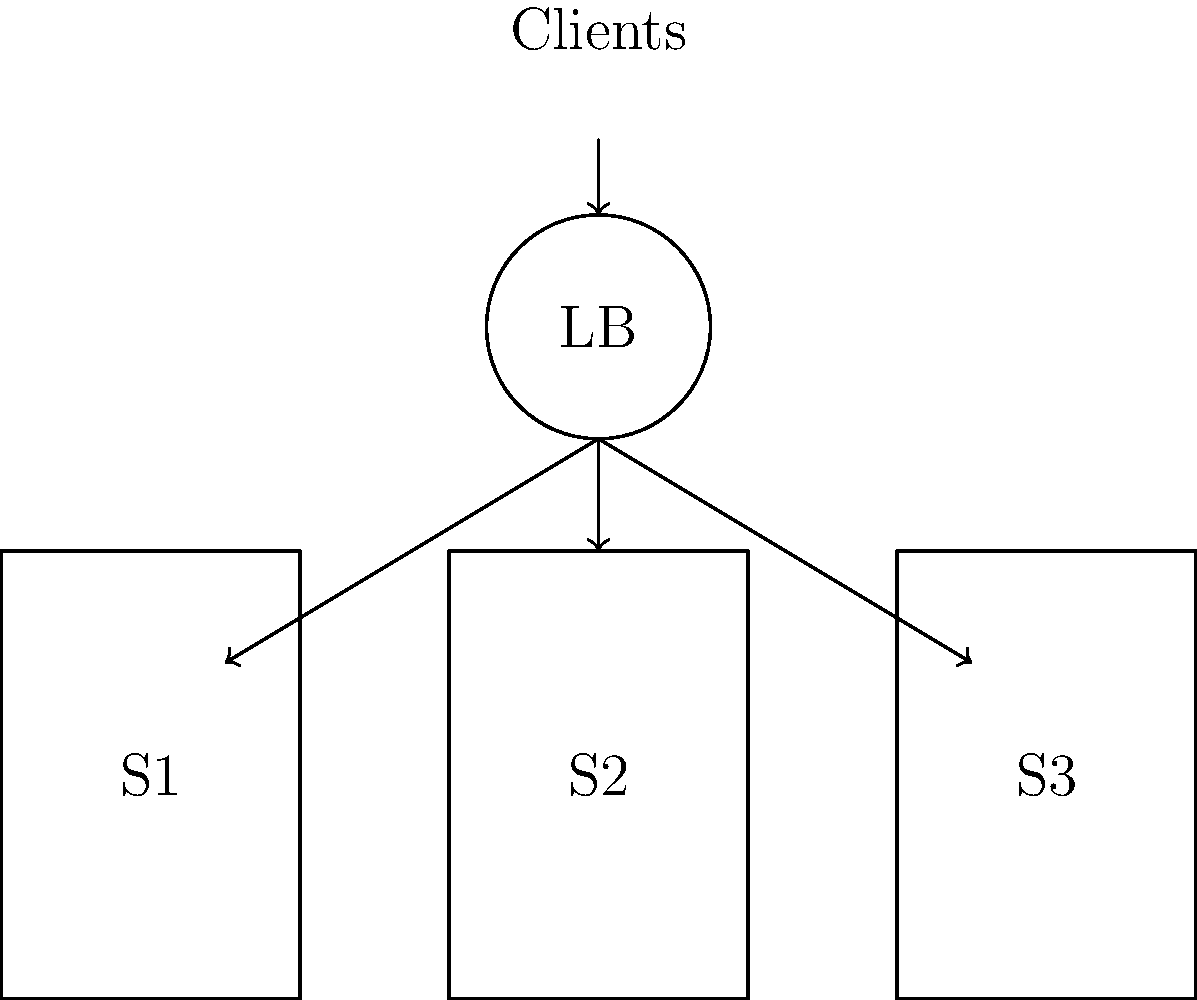In the claims management system architecture shown above, which load balancing algorithm would be most effective for distributing incoming claims processing requests across multiple servers to ensure optimal performance and resource utilization? To determine the most effective load balancing algorithm for this claims management system, we need to consider the following factors:

1. Nature of claims processing: Claims processing typically involves varying levels of complexity and processing time for different types of claims.

2. Server capabilities: Servers S1, S2, and S3 may have different processing capacities or specialized functions.

3. System goals: The primary objectives are to ensure optimal performance and resource utilization.

Given these considerations, the most effective load balancing algorithm would be the Least Connections algorithm. Here's why:

1. Dynamic workload distribution: The Least Connections algorithm assigns new requests to the server with the fewest active connections. This ensures that no single server becomes overwhelmed while others remain underutilized.

2. Adapts to varying claim complexities: Since some claims may take longer to process than others, this algorithm helps distribute the workload more evenly by considering the current load on each server.

3. Efficient resource utilization: By sending new requests to the least busy server, it maximizes the use of available resources across all servers.

4. Improved response times: Distributing requests based on current load helps maintain consistent response times for claim processing.

5. Scalability: This algorithm works well when adding or removing servers from the pool, making it suitable for a growing claims management system.

Other algorithms like Round Robin or IP Hash might not be as effective because they don't consider the current load on each server, potentially leading to uneven distribution and suboptimal resource utilization.
Answer: Least Connections algorithm 